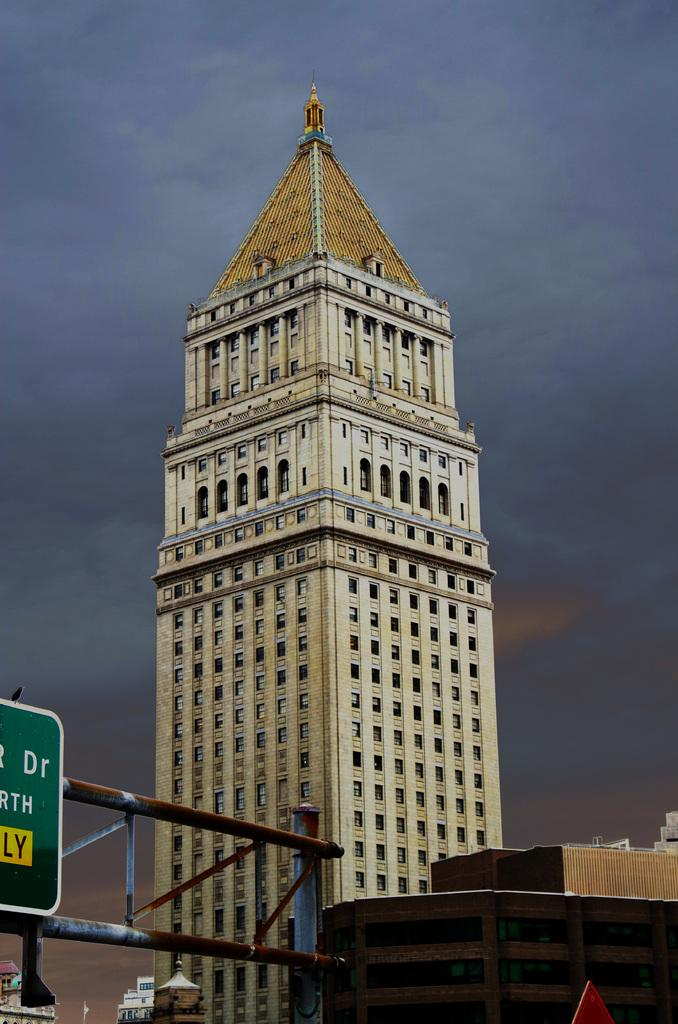What type of structure can be seen in the image? There are metal poles in the image. What is attached to the metal poles? There is a green colored board attached to the poles. What can be seen in the background of the image? Buildings and the sky are visible in the background of the image. What type of farmer is shown working in the image? There is no farmer present in the image. What time of day is depicted in the image? The time of day cannot be determined from the image, as there are no specific indicators of time. 